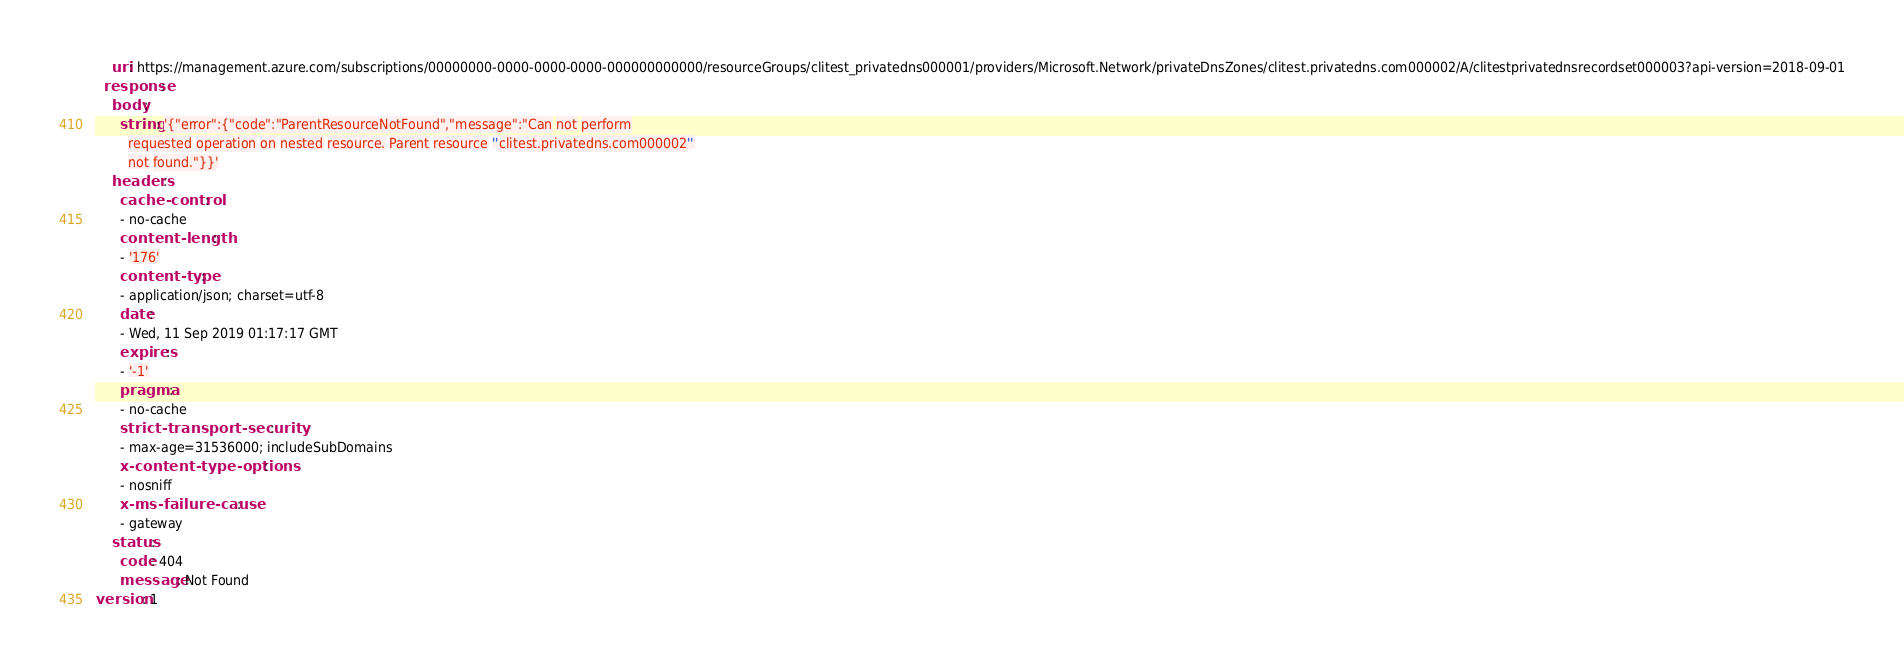Convert code to text. <code><loc_0><loc_0><loc_500><loc_500><_YAML_>    uri: https://management.azure.com/subscriptions/00000000-0000-0000-0000-000000000000/resourceGroups/clitest_privatedns000001/providers/Microsoft.Network/privateDnsZones/clitest.privatedns.com000002/A/clitestprivatednsrecordset000003?api-version=2018-09-01
  response:
    body:
      string: '{"error":{"code":"ParentResourceNotFound","message":"Can not perform
        requested operation on nested resource. Parent resource ''clitest.privatedns.com000002''
        not found."}}'
    headers:
      cache-control:
      - no-cache
      content-length:
      - '176'
      content-type:
      - application/json; charset=utf-8
      date:
      - Wed, 11 Sep 2019 01:17:17 GMT
      expires:
      - '-1'
      pragma:
      - no-cache
      strict-transport-security:
      - max-age=31536000; includeSubDomains
      x-content-type-options:
      - nosniff
      x-ms-failure-cause:
      - gateway
    status:
      code: 404
      message: Not Found
version: 1
</code> 